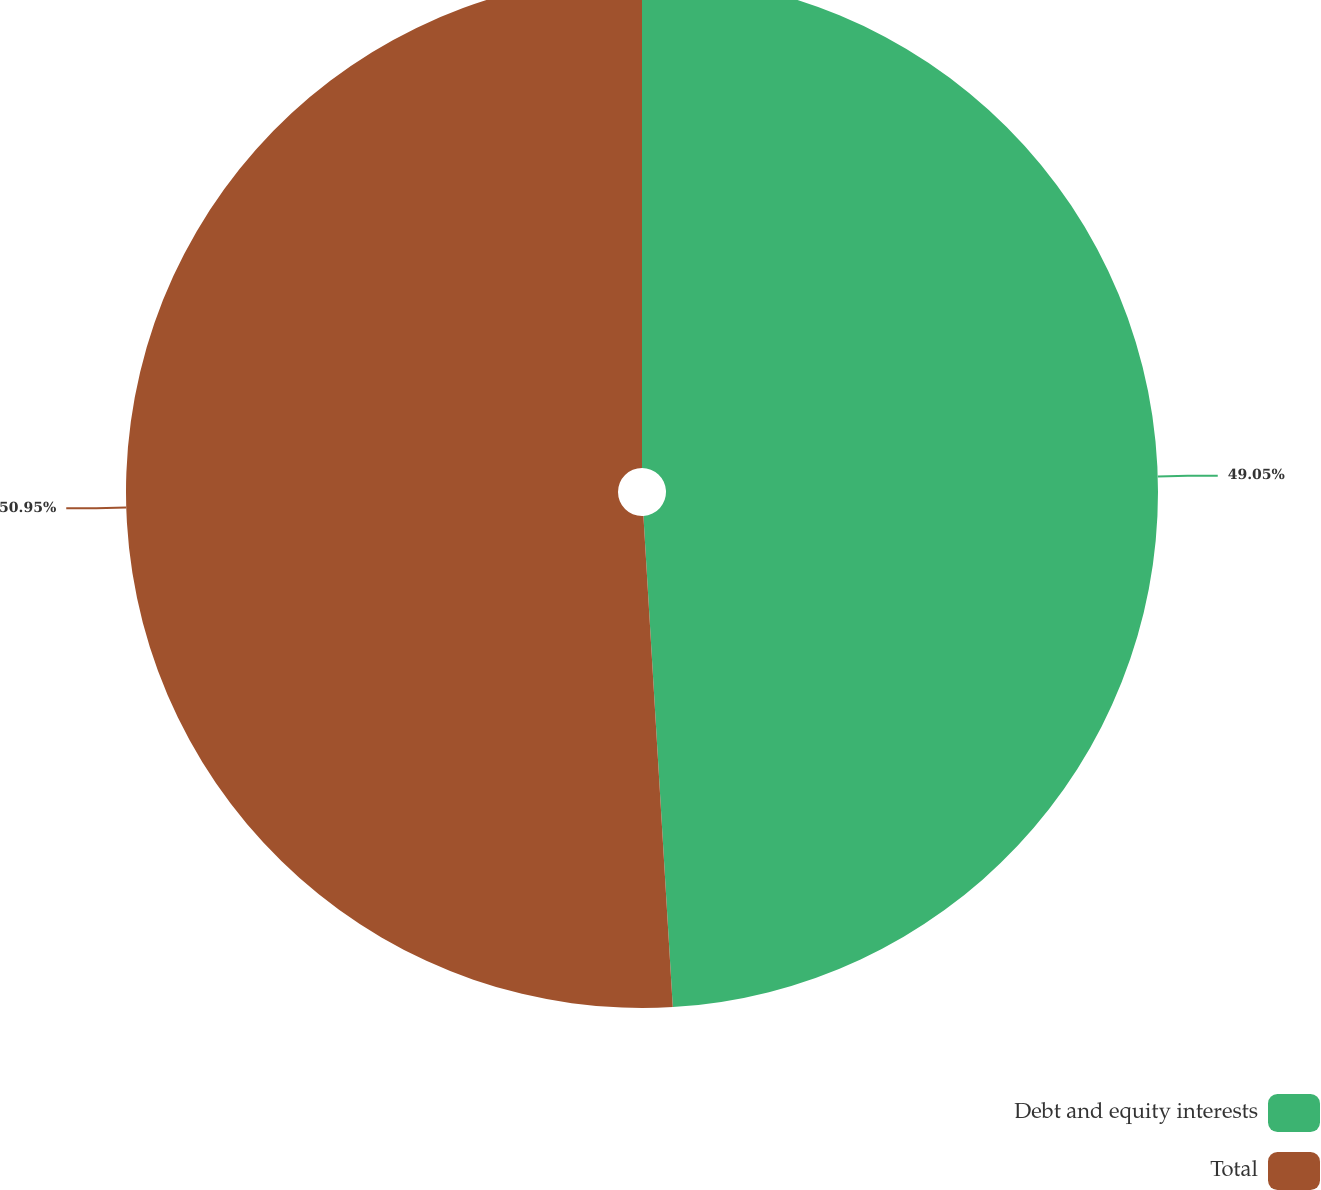Convert chart. <chart><loc_0><loc_0><loc_500><loc_500><pie_chart><fcel>Debt and equity interests<fcel>Total<nl><fcel>49.05%<fcel>50.95%<nl></chart> 